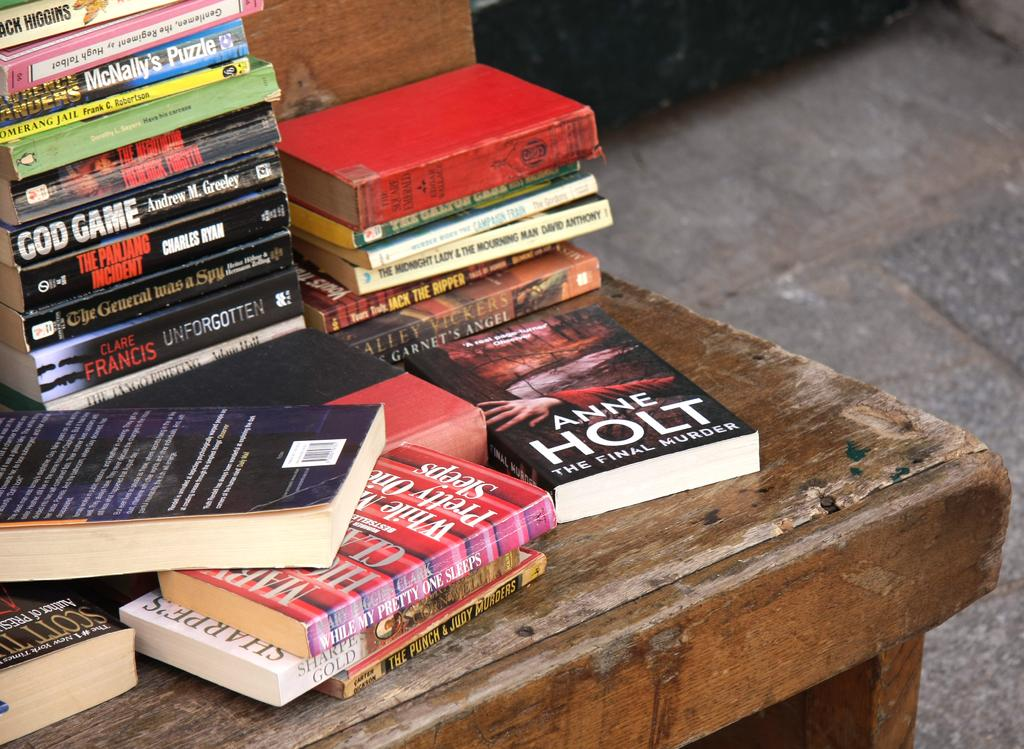<image>
Share a concise interpretation of the image provided. A pile of books including God Game, Unforgotten, and The Final Murder. 